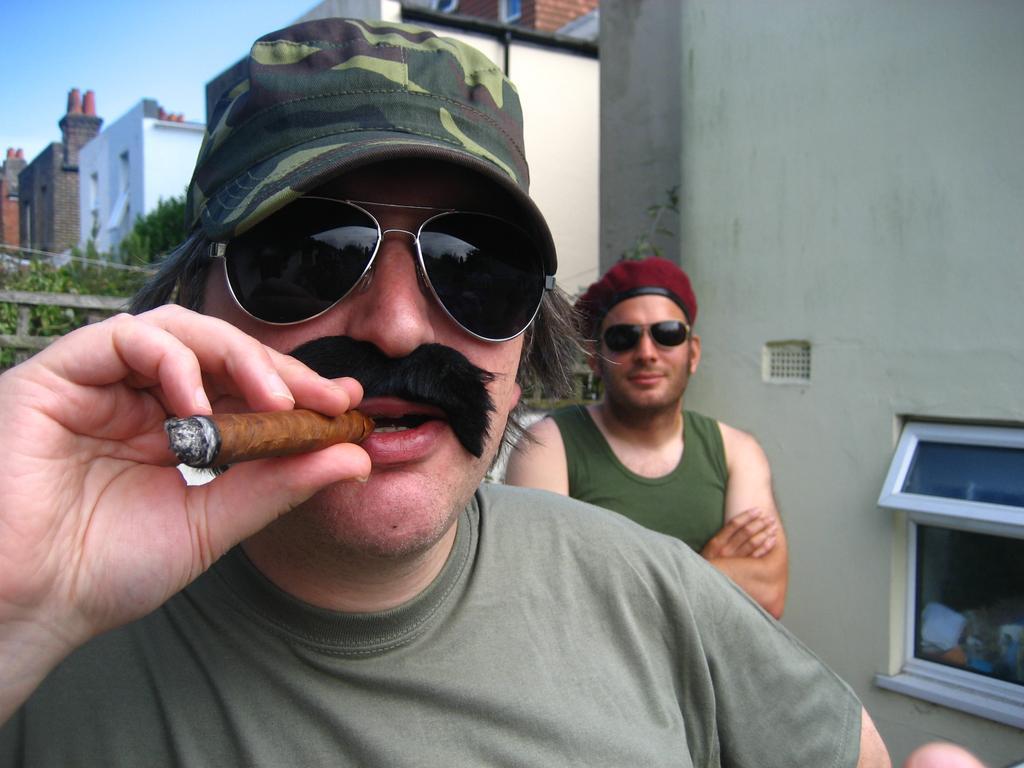How would you summarize this image in a sentence or two? In front of the image there is a person smoking a cigar, behind him there is another person, beside him there is a glass window on the wall, behind him there is a wooden fence, behind the fence there is a cable, trees and buildings. 